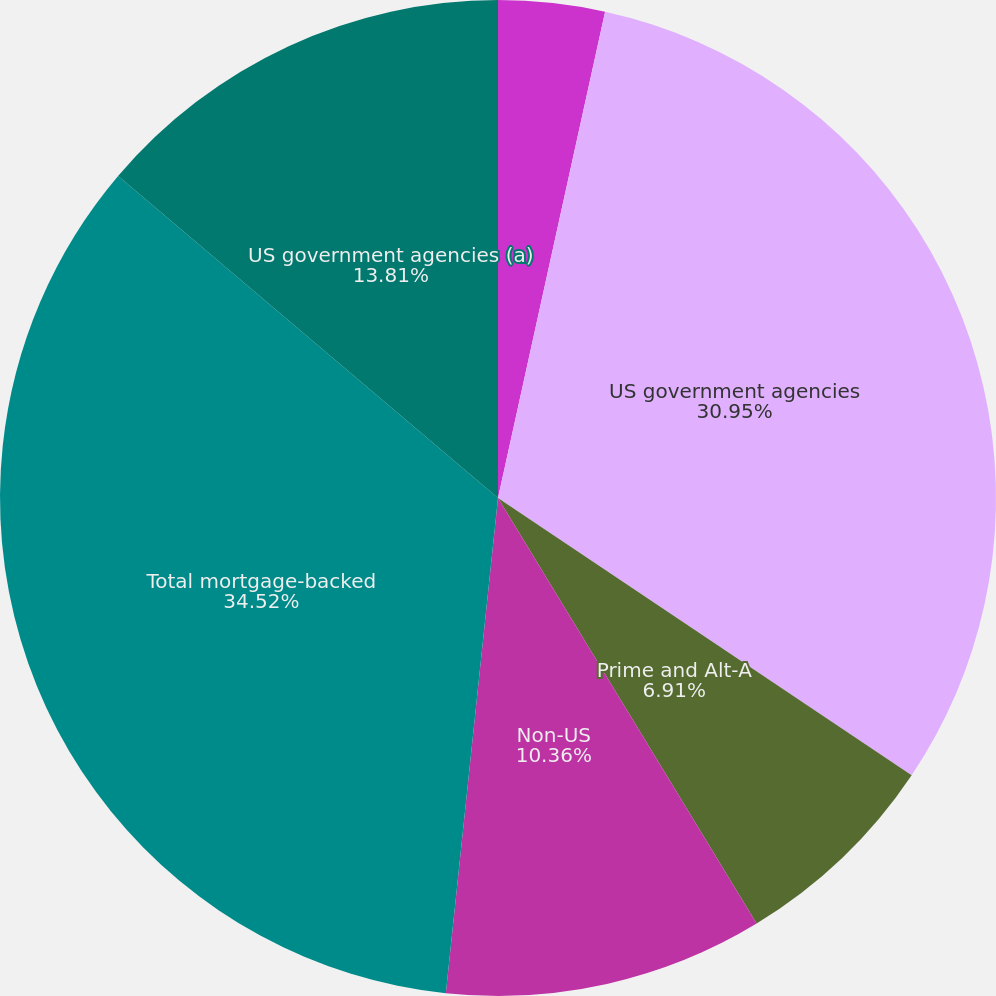<chart> <loc_0><loc_0><loc_500><loc_500><pie_chart><fcel>(in millions)<fcel>US government agencies<fcel>Prime and Alt-A<fcel>Subprime<fcel>Non-US<fcel>Total mortgage-backed<fcel>US government agencies (a)<nl><fcel>3.45%<fcel>30.95%<fcel>6.91%<fcel>0.0%<fcel>10.36%<fcel>34.52%<fcel>13.81%<nl></chart> 